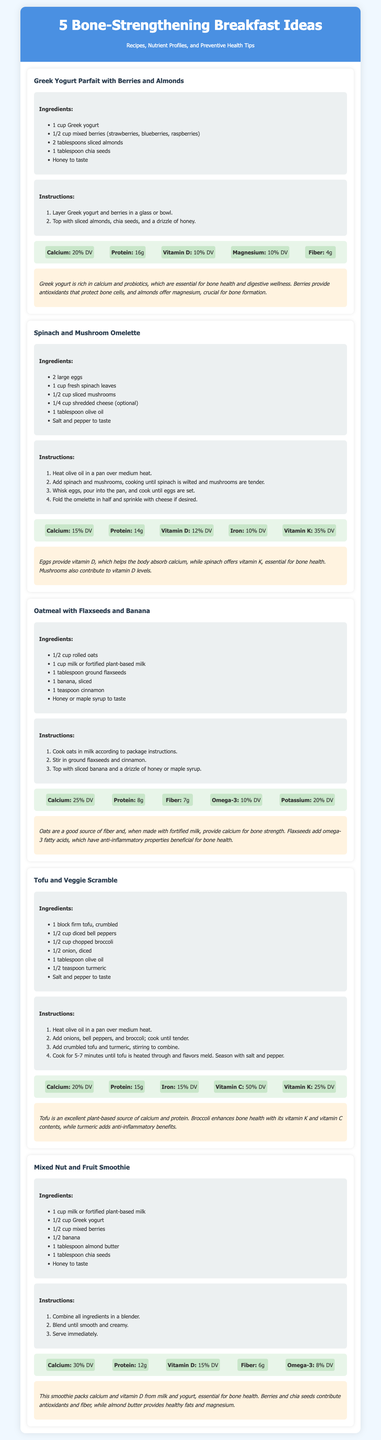What is the first recipe listed? The first recipe mentioned in the document is "Greek Yogurt Parfait with Berries and Almonds."
Answer: Greek Yogurt Parfait with Berries and Almonds How many grams of protein does the Spinach and Mushroom Omelette contain? The nutrient profile of the Spinach and Mushroom Omelette includes 14 grams of protein.
Answer: 14g What is the calcium percentage provided by the Oatmeal with Flaxseeds and Banana? The Oatmeal with Flaxseeds and Banana provides 25% of the Daily Value for calcium.
Answer: 25% DV Which ingredient is common in both the Greek Yogurt Parfait and the Mixed Nut and Fruit Smoothie? Both recipes include Greek yogurt as an ingredient.
Answer: Greek yogurt What health benefit contributes to bone health from the Spinach and Mushroom Omelette? The omelette is rich in vitamin K, which is essential for bone health.
Answer: Vitamin K What method is used to prepare the Mixed Nut and Fruit Smoothie? The Mixed Nut and Fruit Smoothie is prepared by combining all ingredients in a blender and blending until smooth.
Answer: Blending Which recipe contains turmeric as an ingredient? The Tofu and Veggie Scramble includes turmeric.
Answer: Tofu and Veggie Scramble How much calcium does the Tofu and Veggie Scramble provide? The Tofu and Veggie Scramble provides 20% of the Daily Value for calcium.
Answer: 20% DV 